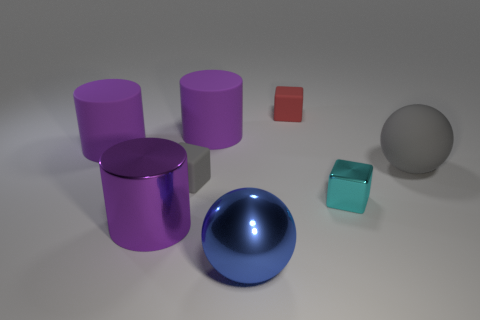The cyan thing is what shape?
Make the answer very short. Cube. How many objects are matte things or small purple rubber balls?
Ensure brevity in your answer.  5. There is a small block that is in front of the small gray object; is it the same color as the tiny rubber object behind the big gray sphere?
Offer a terse response. No. How many other things are the same shape as the tiny shiny thing?
Make the answer very short. 2. Are any tiny blue matte cubes visible?
Your response must be concise. No. How many objects are either red objects or cylinders behind the rubber sphere?
Provide a short and direct response. 3. There is a purple cylinder right of the purple metallic cylinder; is it the same size as the cyan shiny object?
Make the answer very short. No. How many other things are there of the same size as the cyan shiny block?
Offer a very short reply. 2. What color is the matte ball?
Offer a terse response. Gray. There is a sphere to the left of the tiny red matte object; what is it made of?
Make the answer very short. Metal. 